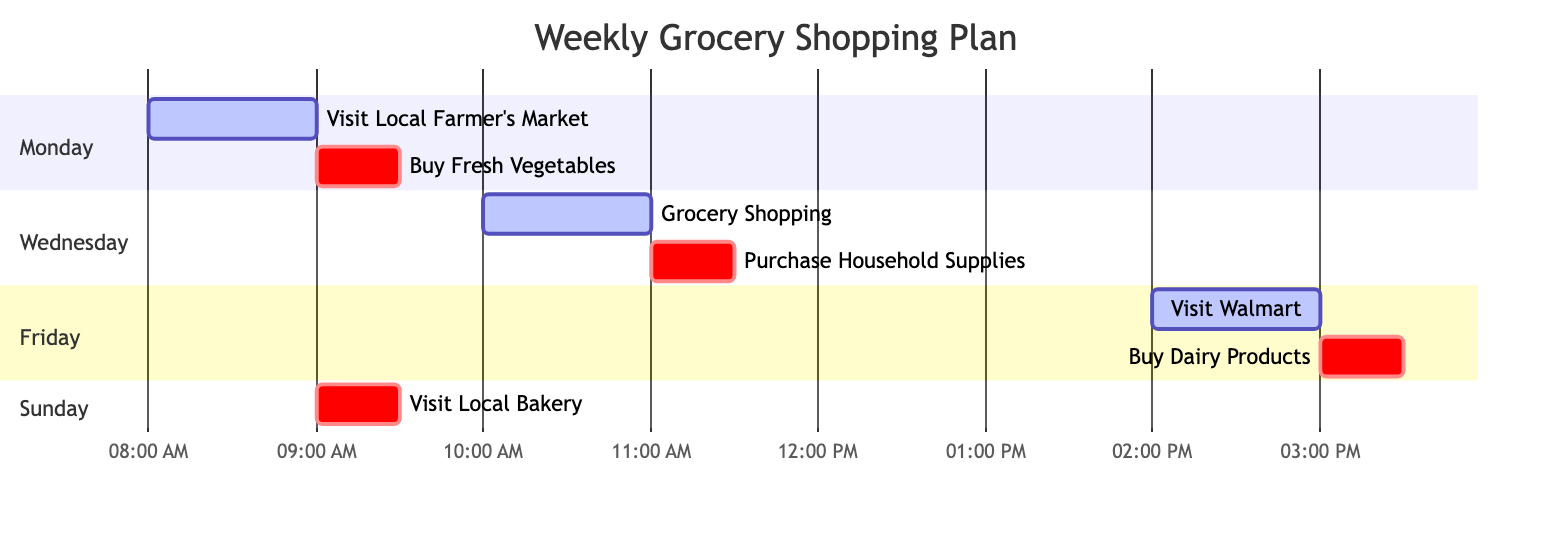What is the first task on Monday? The diagram shows that the first task on Monday is "Visit Local Farmer's Market," which starts at 08:00 AM.
Answer: Visit Local Farmer's Market How long is the task "Buy Fresh Vegetables"? The task "Buy Fresh Vegetables" is scheduled to last for 30 minutes, starting immediately after the previous task "Visit Local Farmer's Market," which ends at 09:00 AM.
Answer: 30 minutes How many tasks are scheduled on Wednesday? On Wednesday, there are two tasks scheduled: "Grocery Shopping" and "Purchase Household Supplies."
Answer: 2 Which store is visited last in the week? The last store visited in the week is "Walmart" on Friday, where the second task is to "Buy Dairy Products."
Answer: Walmart What is the duration of the task "Visit Local Bakery"? The task "Visit Local Bakery" has a duration of 30 minutes, as indicated in the diagram.
Answer: 30 minutes What task occurs immediately after "Grocery Shopping"? The task that occurs immediately after "Grocery Shopping" is "Purchase Household Supplies," as shown in the Gantt chart.
Answer: Purchase Household Supplies Which day has the longest duration of time spent on grocery shopping? On Wednesday, the total duration is 1 hour spent on "Grocery Shopping" plus 30 minutes on "Purchase Household Supplies," making it the longest at 1.5 hours.
Answer: Wednesday On which day is there only one task scheduled? Sunday is the only day where there is only one task scheduled, which is "Visit Local Bakery."
Answer: Sunday What time does the task "Buy Dairy Products" start? The task "Buy Dairy Products" starts at 03:00 PM, right after the "Visit Walmart" task.
Answer: 03:00 PM 